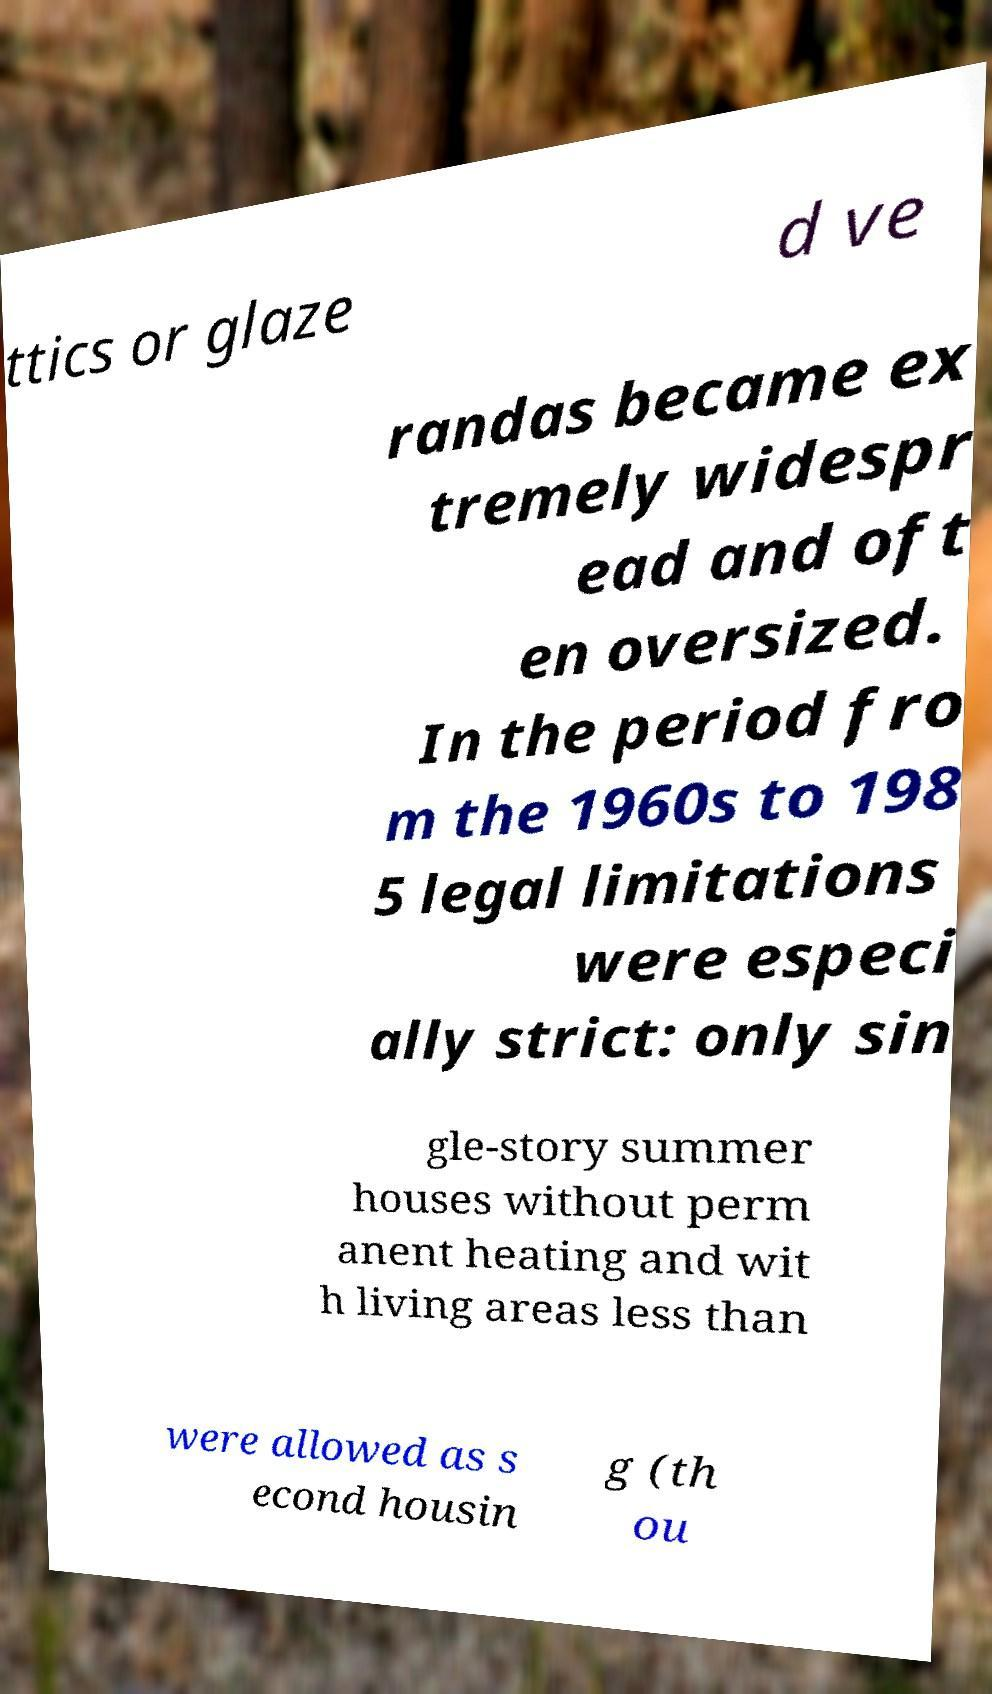For documentation purposes, I need the text within this image transcribed. Could you provide that? ttics or glaze d ve randas became ex tremely widespr ead and oft en oversized. In the period fro m the 1960s to 198 5 legal limitations were especi ally strict: only sin gle-story summer houses without perm anent heating and wit h living areas less than were allowed as s econd housin g (th ou 